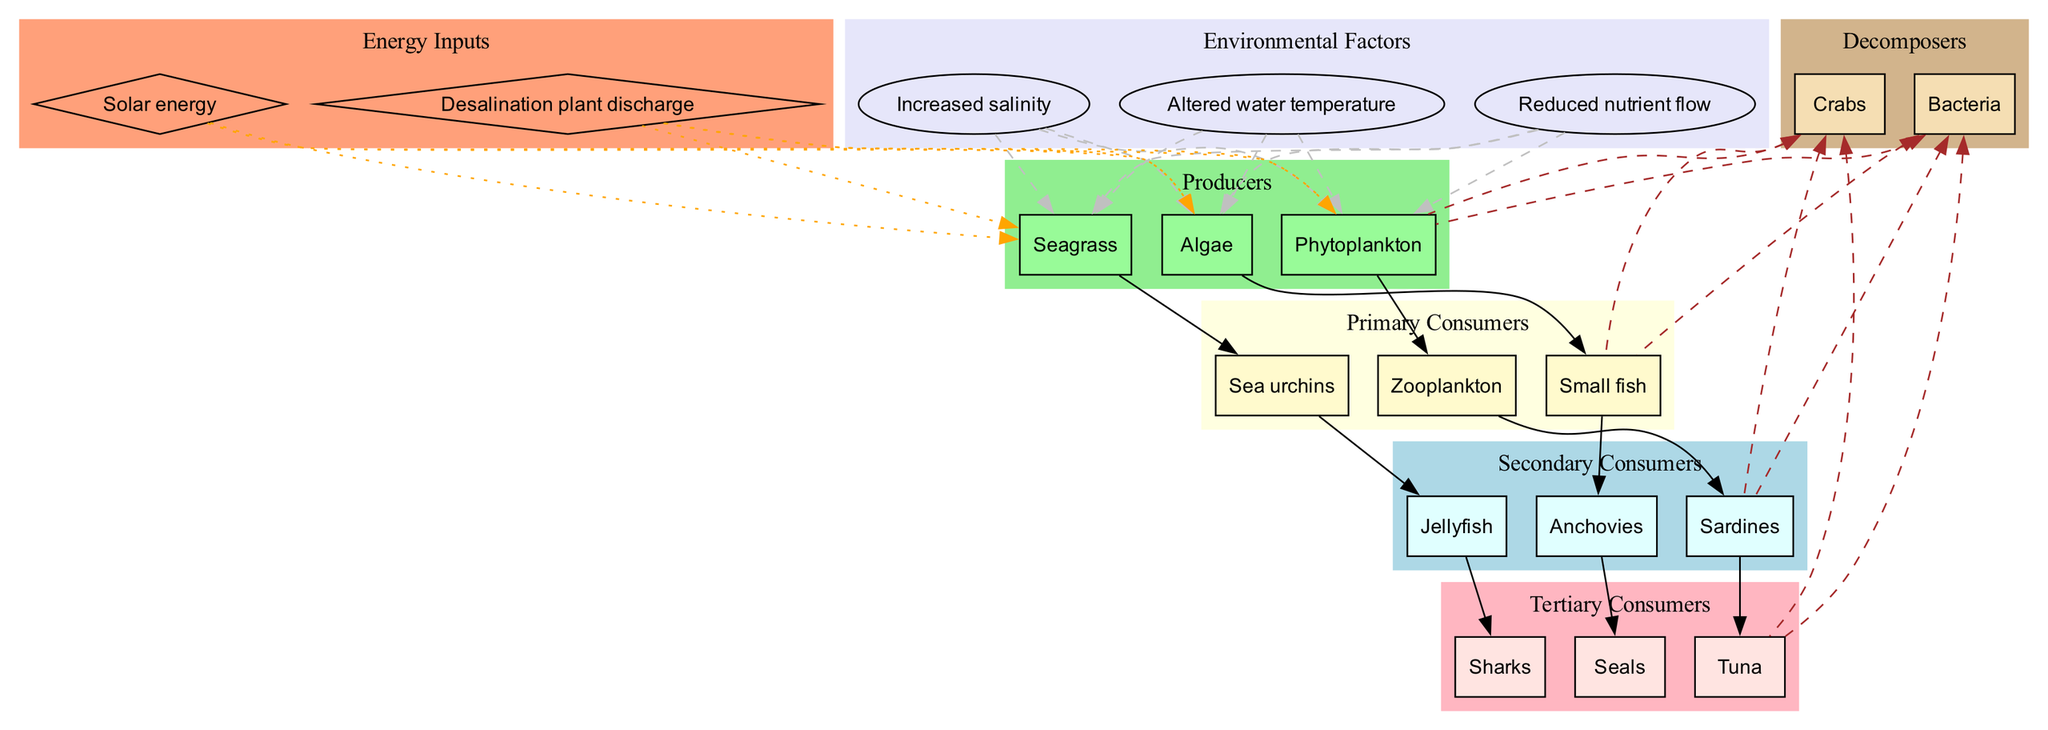What are the primary consumers in the marine ecosystem? The primary consumers are the organisms that directly feed on producers. By looking at the diagram, we see that 'Zooplankton', 'Small fish', and 'Sea urchins' are listed under primary consumers.
Answer: Zooplankton, Small fish, Sea urchins Which organism is at the top of the food chain? The organism at the top of the food chain is the tertiary consumer that has no natural predators shown in the diagram. In this case, 'Sharks' is indicated as a tertiary consumer at the highest level.
Answer: Sharks How many producers are there in total? To find the total number of producers, we count the nodes labeled under the producers category: 'Phytoplankton', 'Seagrass', and 'Algae', giving us a total of three.
Answer: 3 What is the connection between tuna and sardines? The diagram shows a direct edge from 'Sardines' to 'Tuna', which indicates that sardines are a food source for tuna. This means that tuna feeds on sardines in the food web.
Answer: Sardines → Tuna Which environmental factor connects to the producers? The environmental factors labeled in the diagram include increased salinity, altered water temperature, and reduced nutrient flow. The question implies which of these has a visual link shown with dashed edges to the producers. All three factors connect to the producers, indicating their influence.
Answer: Increased salinity, Altered water temperature, Reduced nutrient flow How many tertiary consumers are depicted in the diagram? The tertiary consumers are specified and categorized in the diagram. By identifying the nodes labeled as tertiary consumers, we find 'Tuna', 'Seals', and 'Sharks', resulting in a count of three tertiary consumers.
Answer: 3 What kind of energy inputs are shown affecting the producers? The diagram enumerates energy inputs that interact with the producers, which include 'Solar energy' and 'Desalination plant discharge'. Both these inputs are linked to the producers, indicating their energy sources.
Answer: Solar energy, Desalination plant discharge Which decomposers are linked back to the primary consumers? The decomposers listed in the diagram are 'Bacteria' and 'Crabs'. The dashed edges connecting back from these decomposers indicate their role in breaking down organic matter from the primary consumers like 'Small fish' and others, showing their connection within the ecosystem.
Answer: Bacteria, Crabs 